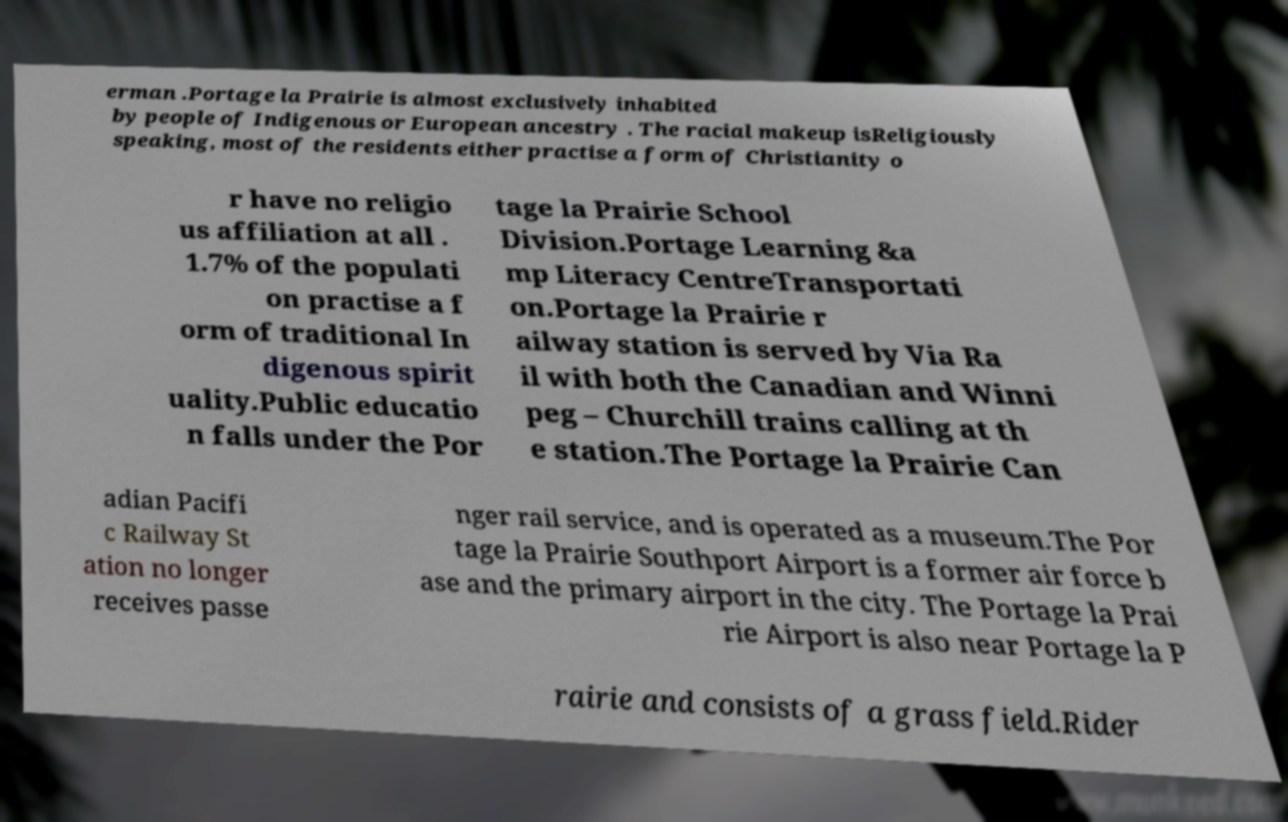I need the written content from this picture converted into text. Can you do that? erman .Portage la Prairie is almost exclusively inhabited by people of Indigenous or European ancestry . The racial makeup isReligiously speaking, most of the residents either practise a form of Christianity o r have no religio us affiliation at all . 1.7% of the populati on practise a f orm of traditional In digenous spirit uality.Public educatio n falls under the Por tage la Prairie School Division.Portage Learning &a mp Literacy CentreTransportati on.Portage la Prairie r ailway station is served by Via Ra il with both the Canadian and Winni peg – Churchill trains calling at th e station.The Portage la Prairie Can adian Pacifi c Railway St ation no longer receives passe nger rail service, and is operated as a museum.The Por tage la Prairie Southport Airport is a former air force b ase and the primary airport in the city. The Portage la Prai rie Airport is also near Portage la P rairie and consists of a grass field.Rider 